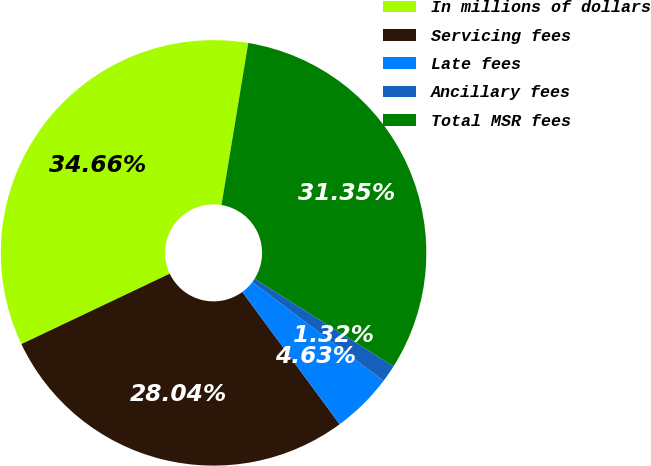Convert chart. <chart><loc_0><loc_0><loc_500><loc_500><pie_chart><fcel>In millions of dollars<fcel>Servicing fees<fcel>Late fees<fcel>Ancillary fees<fcel>Total MSR fees<nl><fcel>34.66%<fcel>28.04%<fcel>4.63%<fcel>1.32%<fcel>31.35%<nl></chart> 